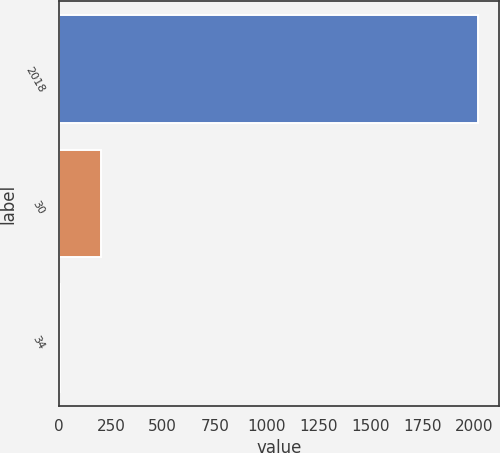Convert chart to OTSL. <chart><loc_0><loc_0><loc_500><loc_500><bar_chart><fcel>2018<fcel>30<fcel>34<nl><fcel>2017<fcel>204.4<fcel>3<nl></chart> 